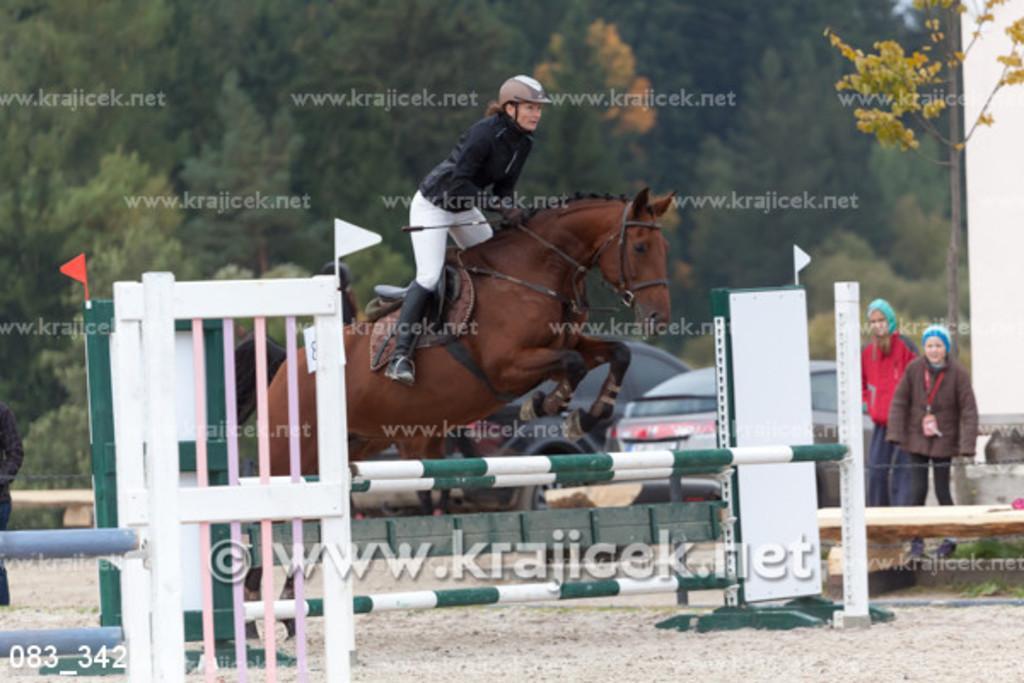Please provide a concise description of this image. In the image we can see there is a woman sitting on the horse and the horse is jumping from the iron rods kept on the stand. The woman is wearing helmet and there are other people standing on the ground. Behind there are trees and the image is little blurry. 